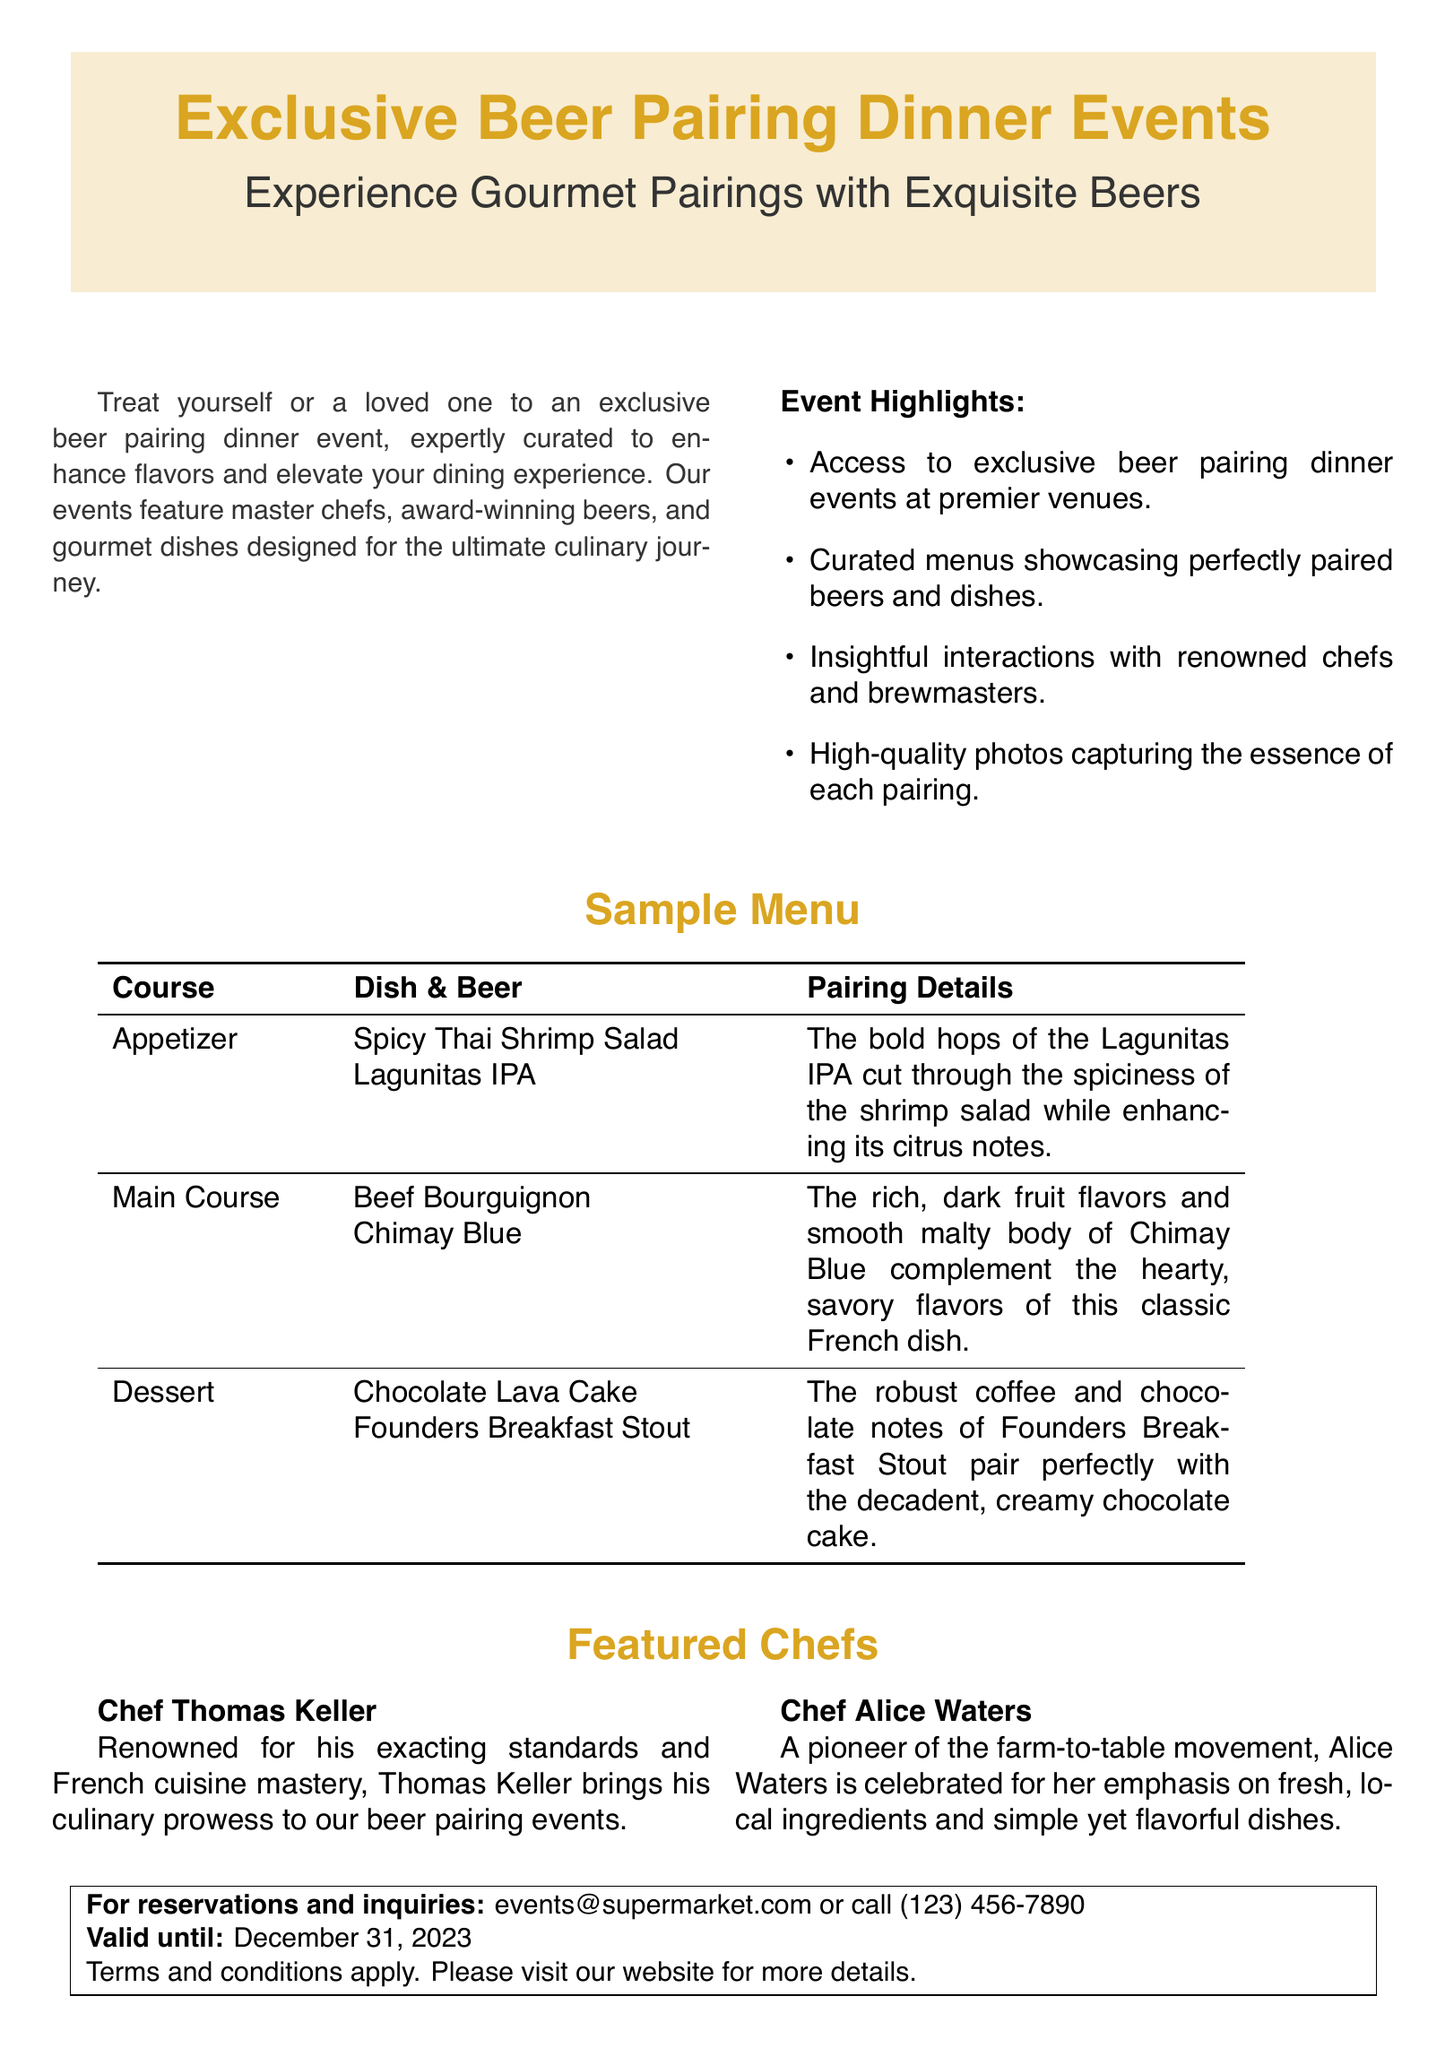What is the title of the event? The title is prominently displayed at the top of the document and indicates the type of event being presented.
Answer: Exclusive Beer Pairing Dinner Events What is the email for reservations? The email is provided in the contact section for inquiries and reservations related to the events.
Answer: events@supermarket.com Who is featured for the appetizer pairing? This information is in the sample menu section of the document, which details the pairings for each course.
Answer: Spicy Thai Shrimp Salad with Lagunitas IPA What is the discount offered on the voucher? The document outlines specifications related to the voucher but does not mention a specific discount; therefore, it requires consideration of what's typically included.
Answer: Not specified What is the valid date until for the voucher? The validity date is stated clearly in the terms and conditions section ensuring clarity for users.
Answer: December 31, 2023 Which chef is known for French cuisine mastery? This information is included in the featured chefs section which highlights particular chefs and their cuisine specialties.
Answer: Chef Thomas Keller What beer is paired with dessert? The pairing for dessert is mentioned in the sample menu, showcasing the specific dish along with its beer pairing.
Answer: Founders Breakfast Stout How many chefs are featured in the document? This question assesses the information provided in the section regarding featured chefs to understand the event's caliber.
Answer: Two 